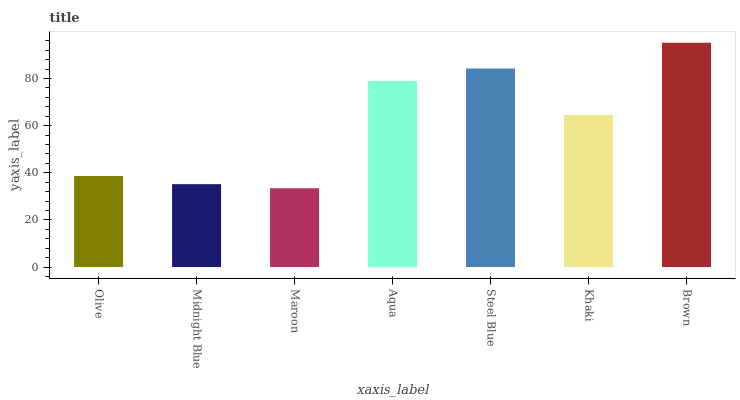Is Maroon the minimum?
Answer yes or no. Yes. Is Brown the maximum?
Answer yes or no. Yes. Is Midnight Blue the minimum?
Answer yes or no. No. Is Midnight Blue the maximum?
Answer yes or no. No. Is Olive greater than Midnight Blue?
Answer yes or no. Yes. Is Midnight Blue less than Olive?
Answer yes or no. Yes. Is Midnight Blue greater than Olive?
Answer yes or no. No. Is Olive less than Midnight Blue?
Answer yes or no. No. Is Khaki the high median?
Answer yes or no. Yes. Is Khaki the low median?
Answer yes or no. Yes. Is Maroon the high median?
Answer yes or no. No. Is Midnight Blue the low median?
Answer yes or no. No. 